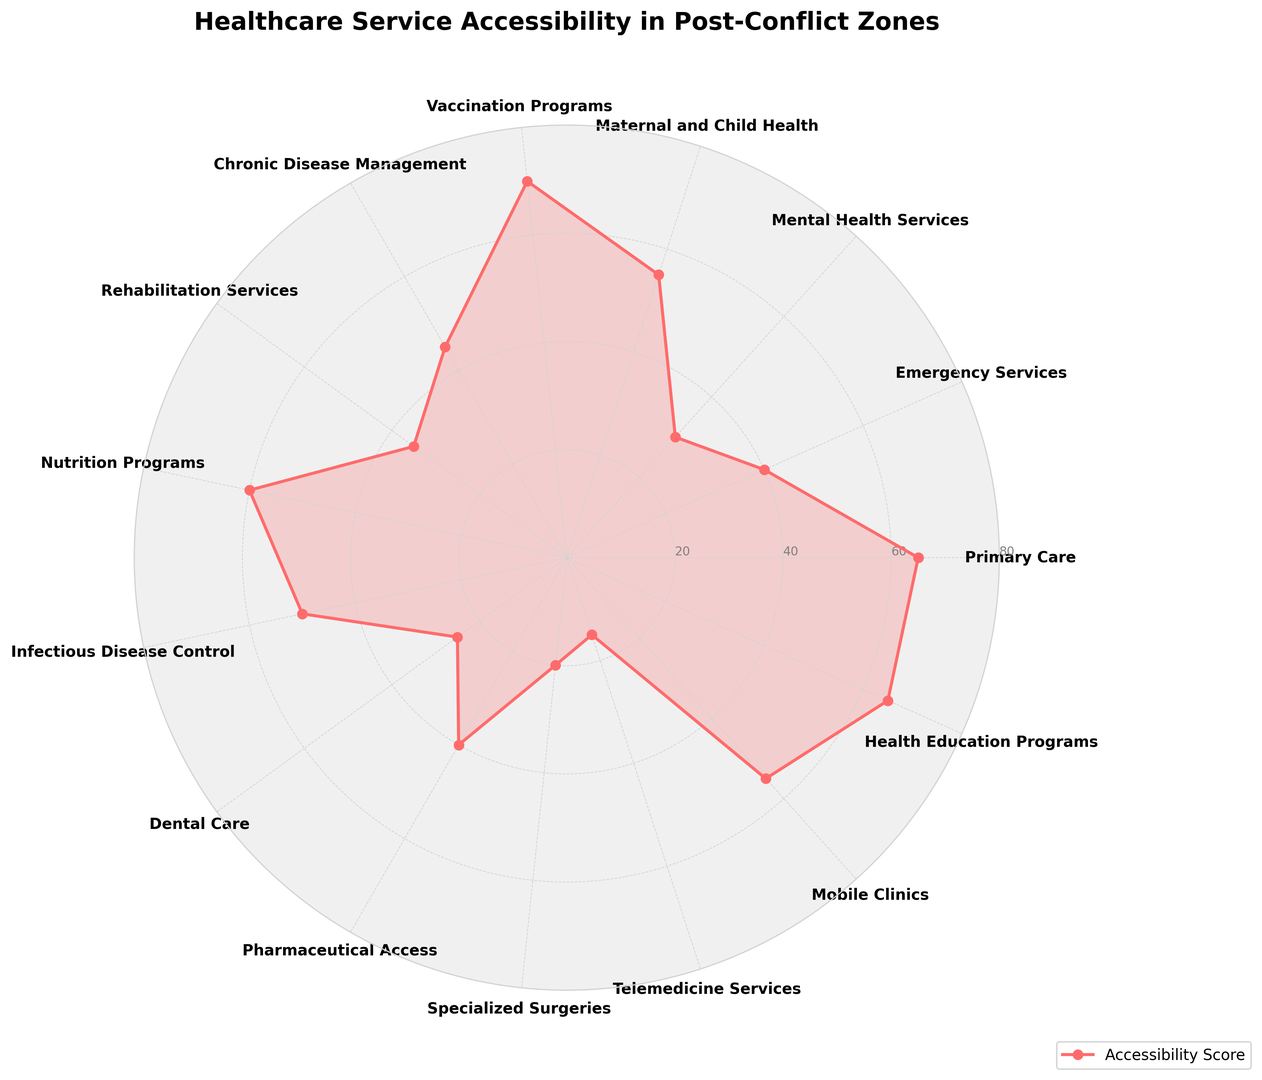Which type of care has the highest accessibility score? The category with the highest score can be identified by visually comparing the length of the radial lines from the center. The longest line signifies the highest score.
Answer: Vaccination Programs Which type of care has the lowest accessibility score? The category with the lowest score can be identified by visually looking for the shortest radial line from the center. The shortest line signifies the lowest score.
Answer: Telemedicine Services How does the accessibility score for Primary Care compare to Dental Care? To compare the scores, look at the length of the lines corresponding to Primary Care and Dental Care. The line for Primary Care is considerably longer than the line for Dental Care.
Answer: Primary Care has a higher score Is Emergency Services accessibility better than Chronic Disease Management? Compare the lines length for Emergency Services and Chronic Disease Management. The line for Emergency Services is shorter than Chronic Disease Management.
Answer: No What's the difference between the accessibility scores of Mental Health Services and Maternal and Child Health? Find the values for Mental Health Services (30) and Maternal and Child Health (55), then calculate the difference: 55 - 30.
Answer: 25 What's the average accessibility score for Primary Care, Emergency Services, and Mental Health Services? Add the values for Primary Care (65), Emergency Services (40), and Mental Health Services (30), then divide by 3 to find the average: (65 + 40 + 30) / 3.
Answer: 45 Which service type is closer in accessibility score to Rehabilitation Services: Telemedicine Services or Health Education Programs? Compare the values of Telemedicine Services (15), Health Education Programs (65), and Rehabilitation Services (35). Health Education Programs (65 - 35 = 30) and Telemedicine Services (35 - 15 = 20).
Answer: Telemedicine Services How many types of care have accessibility scores greater than 50? Count the number of categories with scores above 50. These are Primary Care (65), Vaccination Programs (70), Nutrition Programs (60), Maternal and Child Health (55), and Health Education Programs (65).
Answer: 5 If Primary Care and Health Education Programs are combined, what's their total accessibility score? Add the scores for Primary Care (65) and Health Education Programs (65): 65 + 65.
Answer: 130 Which type of care has twice the accessibility score of Telemedicine Services? Telemedicine Services have a score of 15. Find the type of care with a score of 30 (15 * 2).
Answer: Mental Health Services 